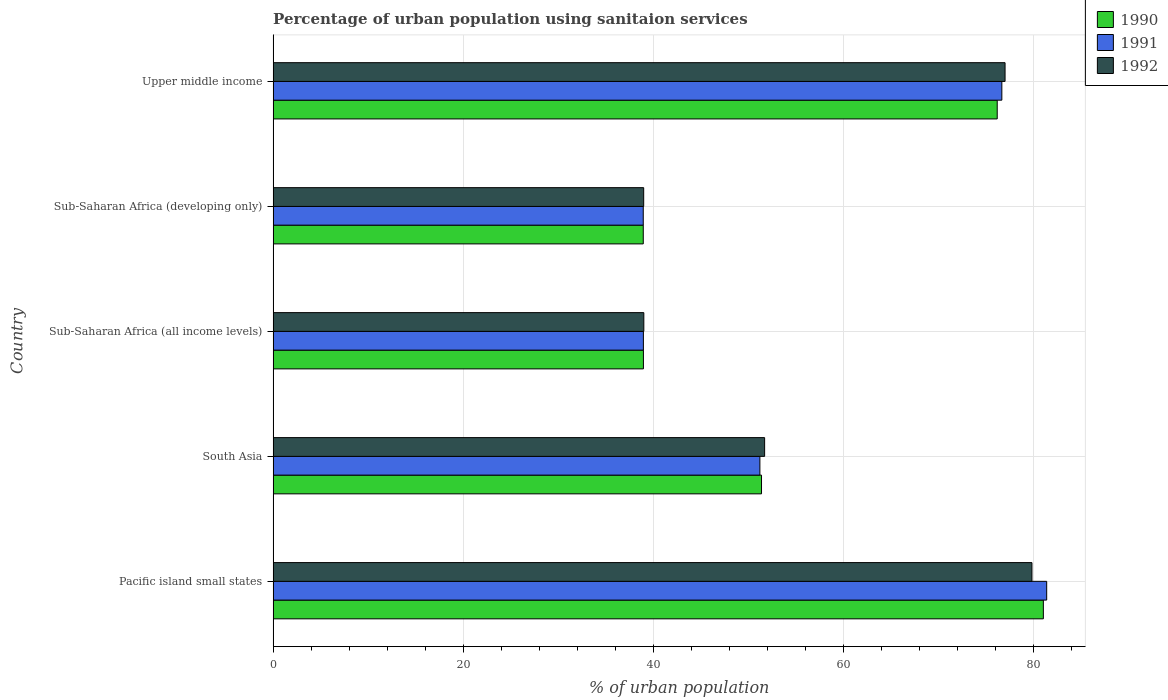How many different coloured bars are there?
Provide a succinct answer. 3. How many groups of bars are there?
Provide a succinct answer. 5. Are the number of bars on each tick of the Y-axis equal?
Ensure brevity in your answer.  Yes. How many bars are there on the 1st tick from the top?
Provide a short and direct response. 3. How many bars are there on the 3rd tick from the bottom?
Ensure brevity in your answer.  3. What is the label of the 1st group of bars from the top?
Provide a succinct answer. Upper middle income. What is the percentage of urban population using sanitaion services in 1991 in Upper middle income?
Provide a succinct answer. 76.68. Across all countries, what is the maximum percentage of urban population using sanitaion services in 1992?
Ensure brevity in your answer.  79.84. Across all countries, what is the minimum percentage of urban population using sanitaion services in 1991?
Your answer should be compact. 38.94. In which country was the percentage of urban population using sanitaion services in 1990 maximum?
Provide a succinct answer. Pacific island small states. In which country was the percentage of urban population using sanitaion services in 1992 minimum?
Offer a terse response. Sub-Saharan Africa (developing only). What is the total percentage of urban population using sanitaion services in 1991 in the graph?
Ensure brevity in your answer.  287.19. What is the difference between the percentage of urban population using sanitaion services in 1992 in Pacific island small states and that in Upper middle income?
Provide a short and direct response. 2.83. What is the difference between the percentage of urban population using sanitaion services in 1991 in Sub-Saharan Africa (developing only) and the percentage of urban population using sanitaion services in 1992 in South Asia?
Keep it short and to the point. -12.77. What is the average percentage of urban population using sanitaion services in 1992 per country?
Give a very brief answer. 57.31. What is the difference between the percentage of urban population using sanitaion services in 1990 and percentage of urban population using sanitaion services in 1992 in Pacific island small states?
Provide a succinct answer. 1.2. What is the ratio of the percentage of urban population using sanitaion services in 1990 in Sub-Saharan Africa (developing only) to that in Upper middle income?
Your answer should be compact. 0.51. What is the difference between the highest and the second highest percentage of urban population using sanitaion services in 1992?
Keep it short and to the point. 2.83. What is the difference between the highest and the lowest percentage of urban population using sanitaion services in 1992?
Your response must be concise. 40.85. In how many countries, is the percentage of urban population using sanitaion services in 1991 greater than the average percentage of urban population using sanitaion services in 1991 taken over all countries?
Your response must be concise. 2. Is the sum of the percentage of urban population using sanitaion services in 1991 in Pacific island small states and Upper middle income greater than the maximum percentage of urban population using sanitaion services in 1990 across all countries?
Your answer should be very brief. Yes. What does the 3rd bar from the bottom in Sub-Saharan Africa (all income levels) represents?
Give a very brief answer. 1992. Is it the case that in every country, the sum of the percentage of urban population using sanitaion services in 1991 and percentage of urban population using sanitaion services in 1990 is greater than the percentage of urban population using sanitaion services in 1992?
Give a very brief answer. Yes. How many bars are there?
Keep it short and to the point. 15. Are all the bars in the graph horizontal?
Offer a very short reply. Yes. How many countries are there in the graph?
Give a very brief answer. 5. What is the difference between two consecutive major ticks on the X-axis?
Ensure brevity in your answer.  20. Are the values on the major ticks of X-axis written in scientific E-notation?
Your answer should be compact. No. What is the title of the graph?
Provide a short and direct response. Percentage of urban population using sanitaion services. Does "1979" appear as one of the legend labels in the graph?
Offer a terse response. No. What is the label or title of the X-axis?
Your answer should be compact. % of urban population. What is the label or title of the Y-axis?
Provide a short and direct response. Country. What is the % of urban population of 1990 in Pacific island small states?
Ensure brevity in your answer.  81.04. What is the % of urban population in 1991 in Pacific island small states?
Ensure brevity in your answer.  81.39. What is the % of urban population of 1992 in Pacific island small states?
Offer a very short reply. 79.84. What is the % of urban population in 1990 in South Asia?
Keep it short and to the point. 51.39. What is the % of urban population of 1991 in South Asia?
Offer a terse response. 51.22. What is the % of urban population of 1992 in South Asia?
Your answer should be compact. 51.72. What is the % of urban population of 1990 in Sub-Saharan Africa (all income levels)?
Offer a very short reply. 38.96. What is the % of urban population of 1991 in Sub-Saharan Africa (all income levels)?
Keep it short and to the point. 38.96. What is the % of urban population in 1992 in Sub-Saharan Africa (all income levels)?
Ensure brevity in your answer.  39.01. What is the % of urban population of 1990 in Sub-Saharan Africa (developing only)?
Make the answer very short. 38.95. What is the % of urban population in 1991 in Sub-Saharan Africa (developing only)?
Make the answer very short. 38.94. What is the % of urban population in 1992 in Sub-Saharan Africa (developing only)?
Provide a succinct answer. 38.99. What is the % of urban population of 1990 in Upper middle income?
Ensure brevity in your answer.  76.19. What is the % of urban population in 1991 in Upper middle income?
Offer a terse response. 76.68. What is the % of urban population of 1992 in Upper middle income?
Give a very brief answer. 77.01. Across all countries, what is the maximum % of urban population of 1990?
Make the answer very short. 81.04. Across all countries, what is the maximum % of urban population in 1991?
Provide a short and direct response. 81.39. Across all countries, what is the maximum % of urban population in 1992?
Give a very brief answer. 79.84. Across all countries, what is the minimum % of urban population of 1990?
Your answer should be very brief. 38.95. Across all countries, what is the minimum % of urban population of 1991?
Give a very brief answer. 38.94. Across all countries, what is the minimum % of urban population of 1992?
Provide a short and direct response. 38.99. What is the total % of urban population in 1990 in the graph?
Make the answer very short. 286.53. What is the total % of urban population in 1991 in the graph?
Offer a very short reply. 287.19. What is the total % of urban population in 1992 in the graph?
Provide a short and direct response. 286.57. What is the difference between the % of urban population of 1990 in Pacific island small states and that in South Asia?
Offer a very short reply. 29.66. What is the difference between the % of urban population in 1991 in Pacific island small states and that in South Asia?
Make the answer very short. 30.18. What is the difference between the % of urban population in 1992 in Pacific island small states and that in South Asia?
Keep it short and to the point. 28.13. What is the difference between the % of urban population in 1990 in Pacific island small states and that in Sub-Saharan Africa (all income levels)?
Give a very brief answer. 42.08. What is the difference between the % of urban population in 1991 in Pacific island small states and that in Sub-Saharan Africa (all income levels)?
Make the answer very short. 42.43. What is the difference between the % of urban population of 1992 in Pacific island small states and that in Sub-Saharan Africa (all income levels)?
Keep it short and to the point. 40.84. What is the difference between the % of urban population of 1990 in Pacific island small states and that in Sub-Saharan Africa (developing only)?
Your response must be concise. 42.1. What is the difference between the % of urban population of 1991 in Pacific island small states and that in Sub-Saharan Africa (developing only)?
Your response must be concise. 42.45. What is the difference between the % of urban population of 1992 in Pacific island small states and that in Sub-Saharan Africa (developing only)?
Ensure brevity in your answer.  40.85. What is the difference between the % of urban population of 1990 in Pacific island small states and that in Upper middle income?
Your response must be concise. 4.86. What is the difference between the % of urban population in 1991 in Pacific island small states and that in Upper middle income?
Offer a very short reply. 4.72. What is the difference between the % of urban population in 1992 in Pacific island small states and that in Upper middle income?
Give a very brief answer. 2.83. What is the difference between the % of urban population of 1990 in South Asia and that in Sub-Saharan Africa (all income levels)?
Your answer should be compact. 12.43. What is the difference between the % of urban population in 1991 in South Asia and that in Sub-Saharan Africa (all income levels)?
Your answer should be very brief. 12.26. What is the difference between the % of urban population of 1992 in South Asia and that in Sub-Saharan Africa (all income levels)?
Offer a very short reply. 12.71. What is the difference between the % of urban population of 1990 in South Asia and that in Sub-Saharan Africa (developing only)?
Provide a short and direct response. 12.44. What is the difference between the % of urban population of 1991 in South Asia and that in Sub-Saharan Africa (developing only)?
Keep it short and to the point. 12.27. What is the difference between the % of urban population in 1992 in South Asia and that in Sub-Saharan Africa (developing only)?
Offer a very short reply. 12.72. What is the difference between the % of urban population in 1990 in South Asia and that in Upper middle income?
Your answer should be very brief. -24.8. What is the difference between the % of urban population in 1991 in South Asia and that in Upper middle income?
Make the answer very short. -25.46. What is the difference between the % of urban population in 1992 in South Asia and that in Upper middle income?
Your response must be concise. -25.3. What is the difference between the % of urban population of 1990 in Sub-Saharan Africa (all income levels) and that in Sub-Saharan Africa (developing only)?
Your answer should be compact. 0.02. What is the difference between the % of urban population of 1991 in Sub-Saharan Africa (all income levels) and that in Sub-Saharan Africa (developing only)?
Make the answer very short. 0.02. What is the difference between the % of urban population of 1992 in Sub-Saharan Africa (all income levels) and that in Sub-Saharan Africa (developing only)?
Your response must be concise. 0.01. What is the difference between the % of urban population in 1990 in Sub-Saharan Africa (all income levels) and that in Upper middle income?
Your response must be concise. -37.23. What is the difference between the % of urban population in 1991 in Sub-Saharan Africa (all income levels) and that in Upper middle income?
Your response must be concise. -37.72. What is the difference between the % of urban population of 1992 in Sub-Saharan Africa (all income levels) and that in Upper middle income?
Offer a very short reply. -38.01. What is the difference between the % of urban population in 1990 in Sub-Saharan Africa (developing only) and that in Upper middle income?
Your answer should be very brief. -37.24. What is the difference between the % of urban population of 1991 in Sub-Saharan Africa (developing only) and that in Upper middle income?
Ensure brevity in your answer.  -37.73. What is the difference between the % of urban population of 1992 in Sub-Saharan Africa (developing only) and that in Upper middle income?
Offer a very short reply. -38.02. What is the difference between the % of urban population in 1990 in Pacific island small states and the % of urban population in 1991 in South Asia?
Provide a succinct answer. 29.83. What is the difference between the % of urban population in 1990 in Pacific island small states and the % of urban population in 1992 in South Asia?
Provide a succinct answer. 29.33. What is the difference between the % of urban population in 1991 in Pacific island small states and the % of urban population in 1992 in South Asia?
Provide a succinct answer. 29.68. What is the difference between the % of urban population of 1990 in Pacific island small states and the % of urban population of 1991 in Sub-Saharan Africa (all income levels)?
Your answer should be very brief. 42.08. What is the difference between the % of urban population in 1990 in Pacific island small states and the % of urban population in 1992 in Sub-Saharan Africa (all income levels)?
Offer a terse response. 42.04. What is the difference between the % of urban population of 1991 in Pacific island small states and the % of urban population of 1992 in Sub-Saharan Africa (all income levels)?
Make the answer very short. 42.39. What is the difference between the % of urban population in 1990 in Pacific island small states and the % of urban population in 1991 in Sub-Saharan Africa (developing only)?
Your answer should be very brief. 42.1. What is the difference between the % of urban population in 1990 in Pacific island small states and the % of urban population in 1992 in Sub-Saharan Africa (developing only)?
Provide a short and direct response. 42.05. What is the difference between the % of urban population in 1991 in Pacific island small states and the % of urban population in 1992 in Sub-Saharan Africa (developing only)?
Offer a very short reply. 42.4. What is the difference between the % of urban population in 1990 in Pacific island small states and the % of urban population in 1991 in Upper middle income?
Your answer should be compact. 4.37. What is the difference between the % of urban population of 1990 in Pacific island small states and the % of urban population of 1992 in Upper middle income?
Offer a terse response. 4.03. What is the difference between the % of urban population of 1991 in Pacific island small states and the % of urban population of 1992 in Upper middle income?
Your answer should be compact. 4.38. What is the difference between the % of urban population in 1990 in South Asia and the % of urban population in 1991 in Sub-Saharan Africa (all income levels)?
Provide a succinct answer. 12.43. What is the difference between the % of urban population in 1990 in South Asia and the % of urban population in 1992 in Sub-Saharan Africa (all income levels)?
Your answer should be very brief. 12.38. What is the difference between the % of urban population of 1991 in South Asia and the % of urban population of 1992 in Sub-Saharan Africa (all income levels)?
Provide a succinct answer. 12.21. What is the difference between the % of urban population in 1990 in South Asia and the % of urban population in 1991 in Sub-Saharan Africa (developing only)?
Offer a very short reply. 12.44. What is the difference between the % of urban population in 1990 in South Asia and the % of urban population in 1992 in Sub-Saharan Africa (developing only)?
Offer a terse response. 12.4. What is the difference between the % of urban population in 1991 in South Asia and the % of urban population in 1992 in Sub-Saharan Africa (developing only)?
Your answer should be compact. 12.23. What is the difference between the % of urban population of 1990 in South Asia and the % of urban population of 1991 in Upper middle income?
Ensure brevity in your answer.  -25.29. What is the difference between the % of urban population of 1990 in South Asia and the % of urban population of 1992 in Upper middle income?
Ensure brevity in your answer.  -25.63. What is the difference between the % of urban population of 1991 in South Asia and the % of urban population of 1992 in Upper middle income?
Provide a short and direct response. -25.8. What is the difference between the % of urban population in 1990 in Sub-Saharan Africa (all income levels) and the % of urban population in 1991 in Sub-Saharan Africa (developing only)?
Offer a terse response. 0.02. What is the difference between the % of urban population in 1990 in Sub-Saharan Africa (all income levels) and the % of urban population in 1992 in Sub-Saharan Africa (developing only)?
Provide a short and direct response. -0.03. What is the difference between the % of urban population of 1991 in Sub-Saharan Africa (all income levels) and the % of urban population of 1992 in Sub-Saharan Africa (developing only)?
Ensure brevity in your answer.  -0.03. What is the difference between the % of urban population in 1990 in Sub-Saharan Africa (all income levels) and the % of urban population in 1991 in Upper middle income?
Offer a very short reply. -37.71. What is the difference between the % of urban population in 1990 in Sub-Saharan Africa (all income levels) and the % of urban population in 1992 in Upper middle income?
Make the answer very short. -38.05. What is the difference between the % of urban population of 1991 in Sub-Saharan Africa (all income levels) and the % of urban population of 1992 in Upper middle income?
Offer a very short reply. -38.05. What is the difference between the % of urban population of 1990 in Sub-Saharan Africa (developing only) and the % of urban population of 1991 in Upper middle income?
Offer a very short reply. -37.73. What is the difference between the % of urban population of 1990 in Sub-Saharan Africa (developing only) and the % of urban population of 1992 in Upper middle income?
Your answer should be compact. -38.07. What is the difference between the % of urban population of 1991 in Sub-Saharan Africa (developing only) and the % of urban population of 1992 in Upper middle income?
Offer a terse response. -38.07. What is the average % of urban population in 1990 per country?
Make the answer very short. 57.31. What is the average % of urban population in 1991 per country?
Give a very brief answer. 57.44. What is the average % of urban population of 1992 per country?
Make the answer very short. 57.31. What is the difference between the % of urban population of 1990 and % of urban population of 1991 in Pacific island small states?
Ensure brevity in your answer.  -0.35. What is the difference between the % of urban population in 1990 and % of urban population in 1992 in Pacific island small states?
Provide a short and direct response. 1.2. What is the difference between the % of urban population of 1991 and % of urban population of 1992 in Pacific island small states?
Your answer should be very brief. 1.55. What is the difference between the % of urban population in 1990 and % of urban population in 1991 in South Asia?
Offer a very short reply. 0.17. What is the difference between the % of urban population in 1990 and % of urban population in 1992 in South Asia?
Keep it short and to the point. -0.33. What is the difference between the % of urban population in 1991 and % of urban population in 1992 in South Asia?
Your answer should be compact. -0.5. What is the difference between the % of urban population of 1990 and % of urban population of 1991 in Sub-Saharan Africa (all income levels)?
Give a very brief answer. 0. What is the difference between the % of urban population in 1990 and % of urban population in 1992 in Sub-Saharan Africa (all income levels)?
Your response must be concise. -0.04. What is the difference between the % of urban population in 1991 and % of urban population in 1992 in Sub-Saharan Africa (all income levels)?
Ensure brevity in your answer.  -0.05. What is the difference between the % of urban population in 1990 and % of urban population in 1991 in Sub-Saharan Africa (developing only)?
Ensure brevity in your answer.  0. What is the difference between the % of urban population of 1990 and % of urban population of 1992 in Sub-Saharan Africa (developing only)?
Provide a short and direct response. -0.04. What is the difference between the % of urban population in 1991 and % of urban population in 1992 in Sub-Saharan Africa (developing only)?
Give a very brief answer. -0.05. What is the difference between the % of urban population in 1990 and % of urban population in 1991 in Upper middle income?
Offer a terse response. -0.49. What is the difference between the % of urban population of 1990 and % of urban population of 1992 in Upper middle income?
Provide a succinct answer. -0.83. What is the difference between the % of urban population in 1991 and % of urban population in 1992 in Upper middle income?
Offer a very short reply. -0.34. What is the ratio of the % of urban population in 1990 in Pacific island small states to that in South Asia?
Your answer should be very brief. 1.58. What is the ratio of the % of urban population in 1991 in Pacific island small states to that in South Asia?
Your answer should be very brief. 1.59. What is the ratio of the % of urban population in 1992 in Pacific island small states to that in South Asia?
Ensure brevity in your answer.  1.54. What is the ratio of the % of urban population in 1990 in Pacific island small states to that in Sub-Saharan Africa (all income levels)?
Offer a terse response. 2.08. What is the ratio of the % of urban population of 1991 in Pacific island small states to that in Sub-Saharan Africa (all income levels)?
Your response must be concise. 2.09. What is the ratio of the % of urban population in 1992 in Pacific island small states to that in Sub-Saharan Africa (all income levels)?
Your answer should be very brief. 2.05. What is the ratio of the % of urban population of 1990 in Pacific island small states to that in Sub-Saharan Africa (developing only)?
Your answer should be compact. 2.08. What is the ratio of the % of urban population of 1991 in Pacific island small states to that in Sub-Saharan Africa (developing only)?
Provide a succinct answer. 2.09. What is the ratio of the % of urban population of 1992 in Pacific island small states to that in Sub-Saharan Africa (developing only)?
Your response must be concise. 2.05. What is the ratio of the % of urban population in 1990 in Pacific island small states to that in Upper middle income?
Offer a terse response. 1.06. What is the ratio of the % of urban population of 1991 in Pacific island small states to that in Upper middle income?
Keep it short and to the point. 1.06. What is the ratio of the % of urban population of 1992 in Pacific island small states to that in Upper middle income?
Provide a short and direct response. 1.04. What is the ratio of the % of urban population of 1990 in South Asia to that in Sub-Saharan Africa (all income levels)?
Your response must be concise. 1.32. What is the ratio of the % of urban population in 1991 in South Asia to that in Sub-Saharan Africa (all income levels)?
Keep it short and to the point. 1.31. What is the ratio of the % of urban population of 1992 in South Asia to that in Sub-Saharan Africa (all income levels)?
Offer a very short reply. 1.33. What is the ratio of the % of urban population in 1990 in South Asia to that in Sub-Saharan Africa (developing only)?
Ensure brevity in your answer.  1.32. What is the ratio of the % of urban population of 1991 in South Asia to that in Sub-Saharan Africa (developing only)?
Keep it short and to the point. 1.32. What is the ratio of the % of urban population in 1992 in South Asia to that in Sub-Saharan Africa (developing only)?
Provide a succinct answer. 1.33. What is the ratio of the % of urban population of 1990 in South Asia to that in Upper middle income?
Your response must be concise. 0.67. What is the ratio of the % of urban population in 1991 in South Asia to that in Upper middle income?
Your response must be concise. 0.67. What is the ratio of the % of urban population of 1992 in South Asia to that in Upper middle income?
Your answer should be very brief. 0.67. What is the ratio of the % of urban population of 1990 in Sub-Saharan Africa (all income levels) to that in Upper middle income?
Offer a very short reply. 0.51. What is the ratio of the % of urban population in 1991 in Sub-Saharan Africa (all income levels) to that in Upper middle income?
Make the answer very short. 0.51. What is the ratio of the % of urban population in 1992 in Sub-Saharan Africa (all income levels) to that in Upper middle income?
Your response must be concise. 0.51. What is the ratio of the % of urban population of 1990 in Sub-Saharan Africa (developing only) to that in Upper middle income?
Provide a short and direct response. 0.51. What is the ratio of the % of urban population of 1991 in Sub-Saharan Africa (developing only) to that in Upper middle income?
Your answer should be very brief. 0.51. What is the ratio of the % of urban population of 1992 in Sub-Saharan Africa (developing only) to that in Upper middle income?
Your answer should be compact. 0.51. What is the difference between the highest and the second highest % of urban population of 1990?
Your answer should be very brief. 4.86. What is the difference between the highest and the second highest % of urban population in 1991?
Make the answer very short. 4.72. What is the difference between the highest and the second highest % of urban population in 1992?
Your answer should be compact. 2.83. What is the difference between the highest and the lowest % of urban population in 1990?
Provide a succinct answer. 42.1. What is the difference between the highest and the lowest % of urban population in 1991?
Offer a very short reply. 42.45. What is the difference between the highest and the lowest % of urban population in 1992?
Your answer should be compact. 40.85. 